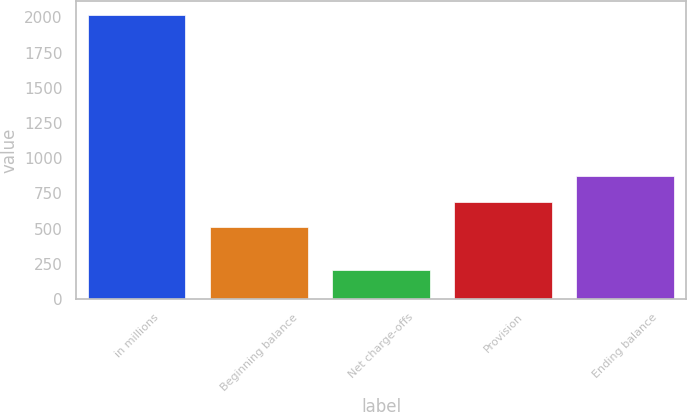<chart> <loc_0><loc_0><loc_500><loc_500><bar_chart><fcel>in millions<fcel>Beginning balance<fcel>Net charge-offs<fcel>Provision<fcel>Ending balance<nl><fcel>2017<fcel>509<fcel>203<fcel>690.4<fcel>871.8<nl></chart> 